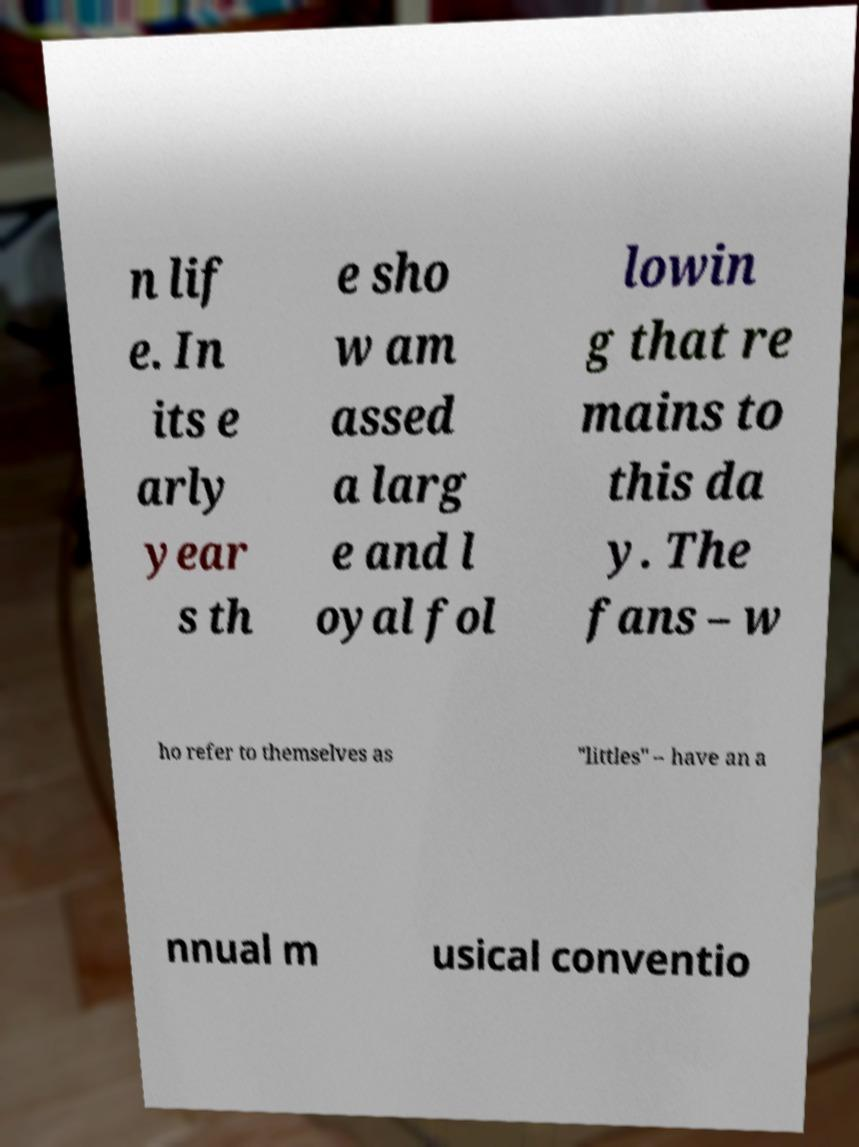Could you extract and type out the text from this image? n lif e. In its e arly year s th e sho w am assed a larg e and l oyal fol lowin g that re mains to this da y. The fans – w ho refer to themselves as "littles" – have an a nnual m usical conventio 